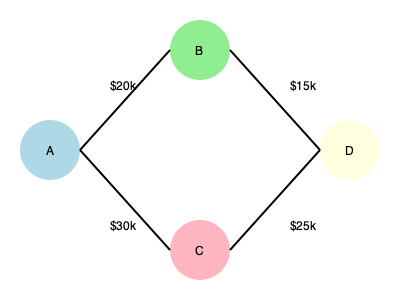In the simplified network diagram representing the flow of illicit funds, if node A is the source of $50,000 in corrupt money, how much reaches the final destination (node D)? To determine the amount of illicit funds reaching node D, we need to follow the money flow through the network:

1. Node A is the source of $50,000 in corrupt money.

2. The money splits into two paths from A:
   - $20,000 goes to node B
   - $30,000 goes to node C

3. From node B:
   - $15,000 flows to node D

4. From node C:
   - $25,000 flows to node D

5. To calculate the total amount reaching node D, we sum the incoming flows:
   $15,000 (from B) + $25,000 (from C) = $40,000

6. We can verify that this makes sense, as some money is likely lost or retained at intermediate nodes (B and C) due to various factors such as laundering fees, bribes, or skimming.

Therefore, out of the original $50,000, a total of $40,000 reaches the final destination (node D).
Answer: $40,000 